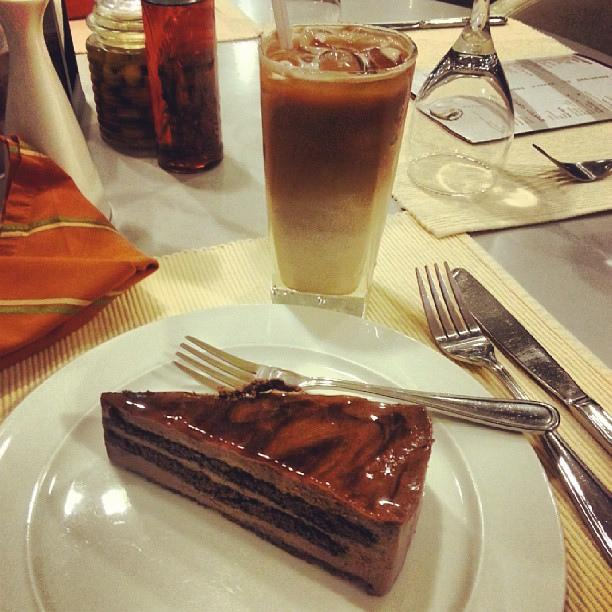What are they expecting to be poured into the upside down glass?

Choices:
A) soda
B) seltzer
C) gatorade
D) wine wine 